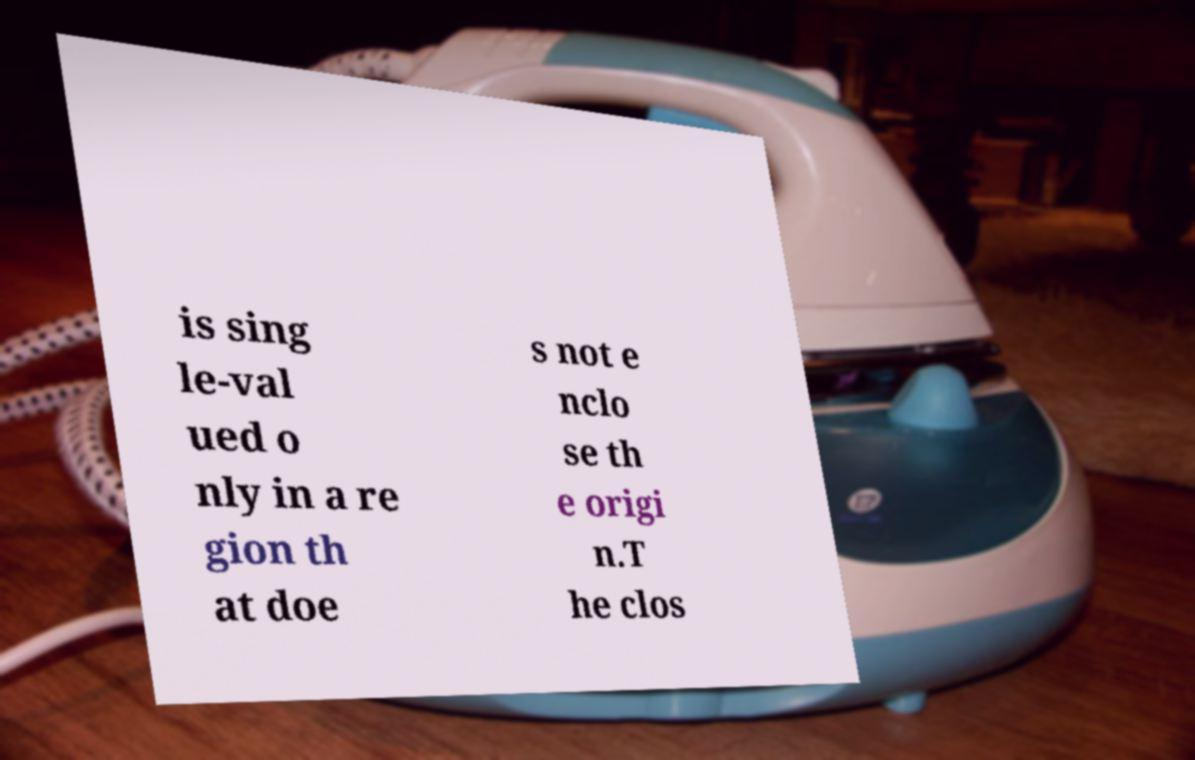Can you accurately transcribe the text from the provided image for me? is sing le-val ued o nly in a re gion th at doe s not e nclo se th e origi n.T he clos 